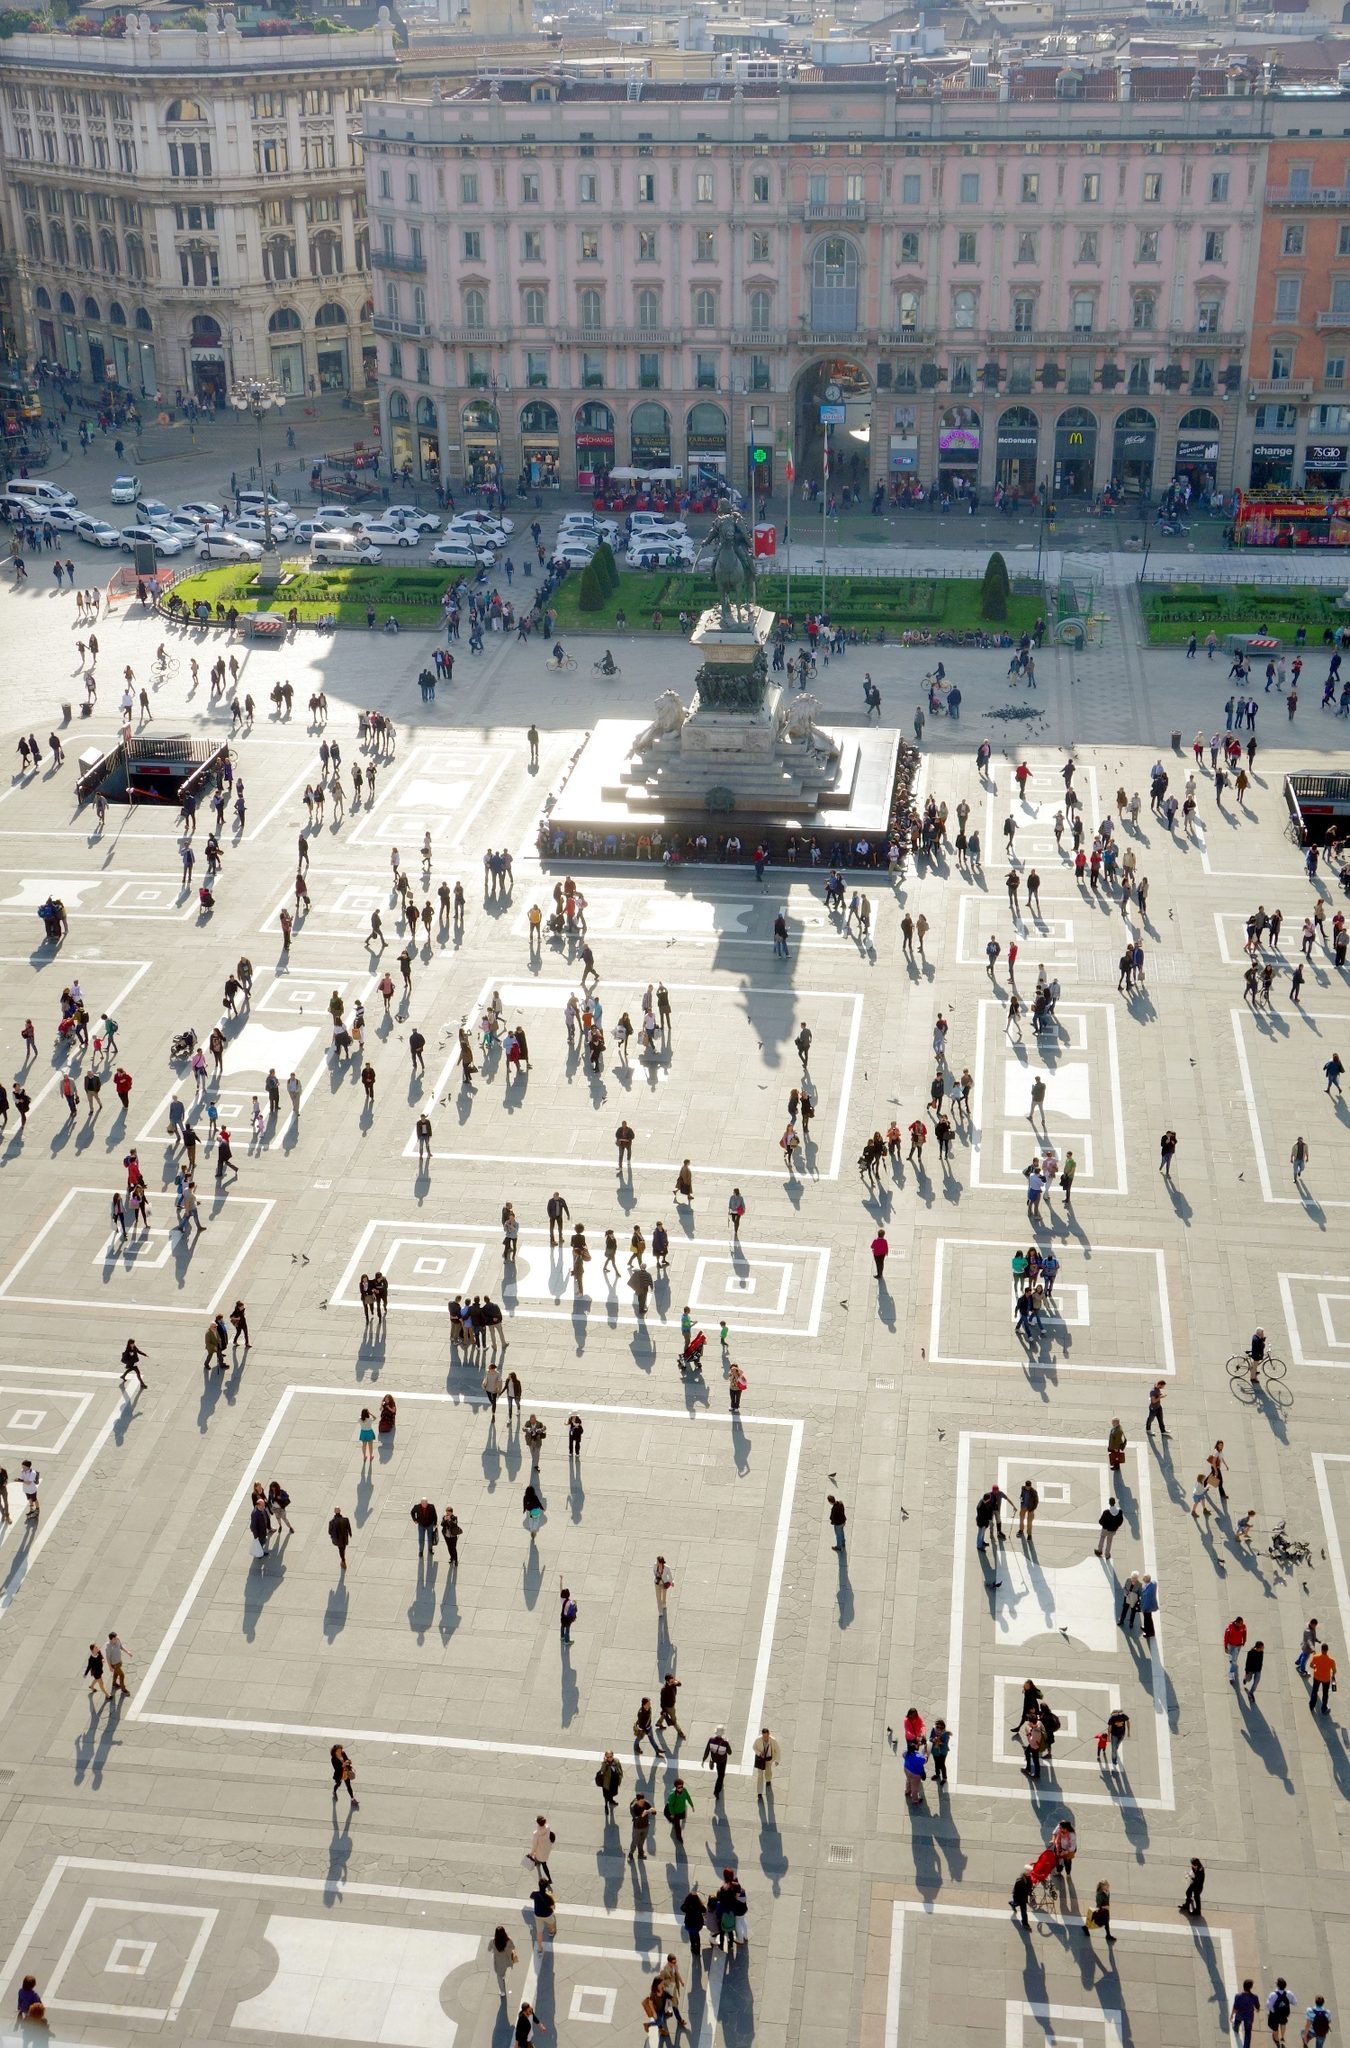What sorts of activities would you expect to see happening in the Piazza del Duomo on a typical day? On a typical day, Piazza del Duomo is bustling with a variety of activities. Visitors and locals alike gather to admire the architectural beauty of the Cathedral and its surroundings. Street performers often entertain the crowds, adding a lively vibe to the square. It's common to see people taking photos, feeding pigeons, and enjoying a leisurely stroll. The numerous cafes and shops around the square are popular spots for people to relax, grab a bite, or indulge in shopping. The area also serves as a popular meeting point for locals and tourists alike. Let's imagine a festival or event is taking place in the Piazza del Duomo. What might that look like? During a festival or event, the Piazza del Duomo transforms into an even more vibrant and bustling venue. Colorful decorations would adorn the square, and stages might be set up for live performances of music, dance, and theatre. The lighting around the Duomo would highlight its stunning architecture, while booths and kiosks line the perimeter, offering local crafts, food, and beverages. Crowds of people, both locals and tourists, would gather to participate in the festivities, creating a festive and energetic atmosphere. The sound of laughter, music, and conversation would fill the air, making it a truly memorable experience. If you stumbled upon an ancient time capsule under the pavement of the Piazza del Duomo, what do you think you might find inside? Opening an ancient time capsule from the Piazza del Duomo could reveal fascinating historical artifacts. You might find aged documents or letters, offering insights into the daily lives of Milanese citizens from centuries past. Historical maps of Milan, coinage used during different eras, and tools or personal items like jewelry or pottery pieces could also be present. Perhaps there would be religious icons or art that reflect the cultural importance of the Duomo through the ages. The items would collectively paint a detailed picture of Milan's rich heritage and evolution. 